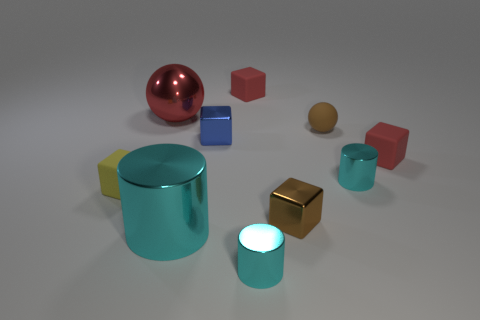Subtract 2 cubes. How many cubes are left? 3 Subtract all gray blocks. Subtract all blue cylinders. How many blocks are left? 5 Subtract all cylinders. How many objects are left? 7 Add 6 big red metal balls. How many big red metal balls are left? 7 Add 4 balls. How many balls exist? 6 Subtract 0 gray cylinders. How many objects are left? 10 Subtract all green metal balls. Subtract all brown things. How many objects are left? 8 